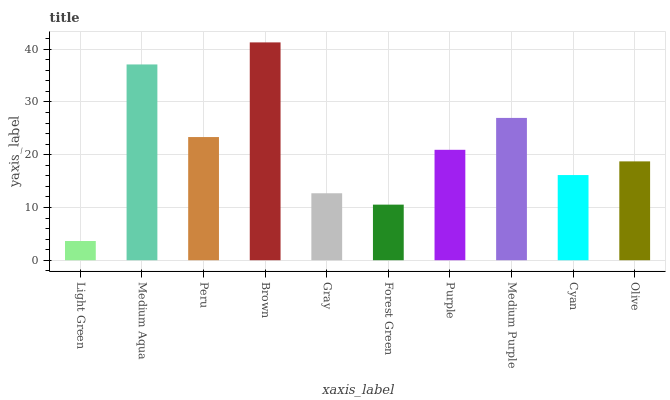Is Light Green the minimum?
Answer yes or no. Yes. Is Brown the maximum?
Answer yes or no. Yes. Is Medium Aqua the minimum?
Answer yes or no. No. Is Medium Aqua the maximum?
Answer yes or no. No. Is Medium Aqua greater than Light Green?
Answer yes or no. Yes. Is Light Green less than Medium Aqua?
Answer yes or no. Yes. Is Light Green greater than Medium Aqua?
Answer yes or no. No. Is Medium Aqua less than Light Green?
Answer yes or no. No. Is Purple the high median?
Answer yes or no. Yes. Is Olive the low median?
Answer yes or no. Yes. Is Medium Purple the high median?
Answer yes or no. No. Is Cyan the low median?
Answer yes or no. No. 